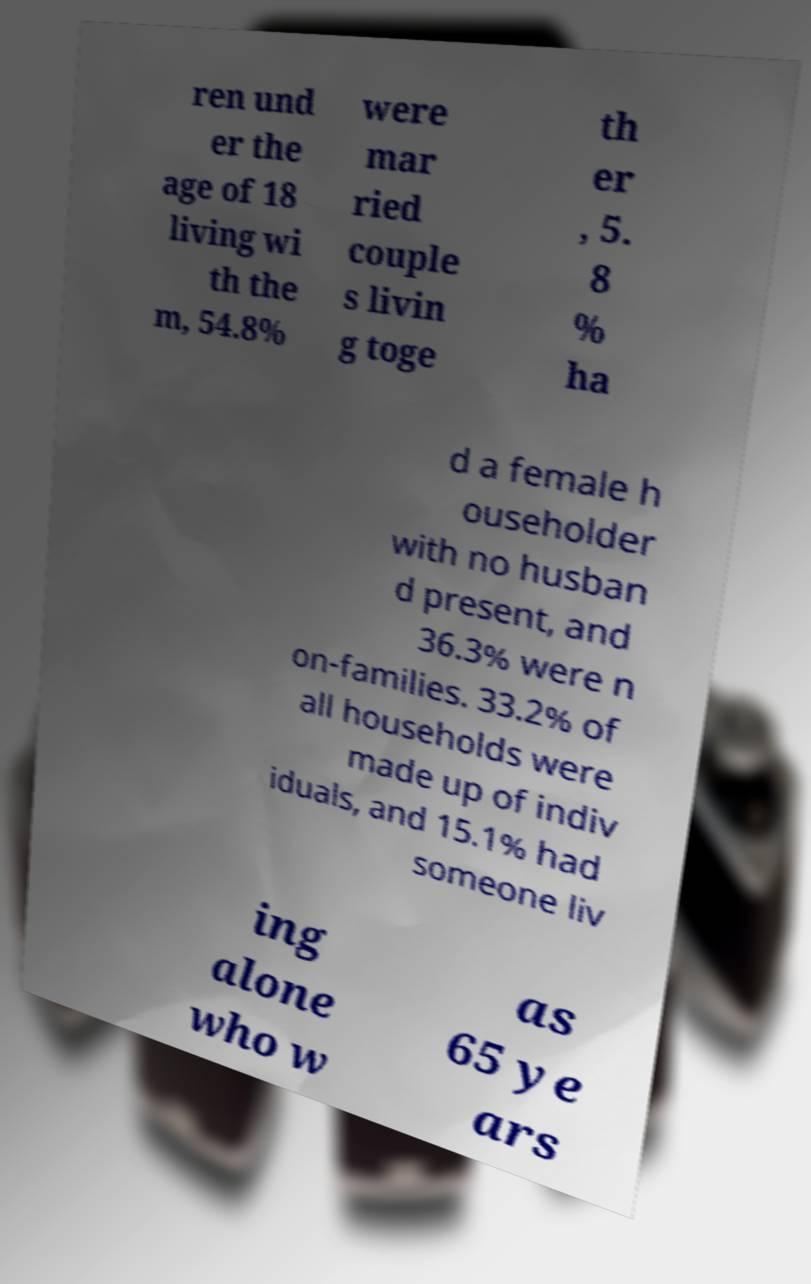Please read and relay the text visible in this image. What does it say? ren und er the age of 18 living wi th the m, 54.8% were mar ried couple s livin g toge th er , 5. 8 % ha d a female h ouseholder with no husban d present, and 36.3% were n on-families. 33.2% of all households were made up of indiv iduals, and 15.1% had someone liv ing alone who w as 65 ye ars 